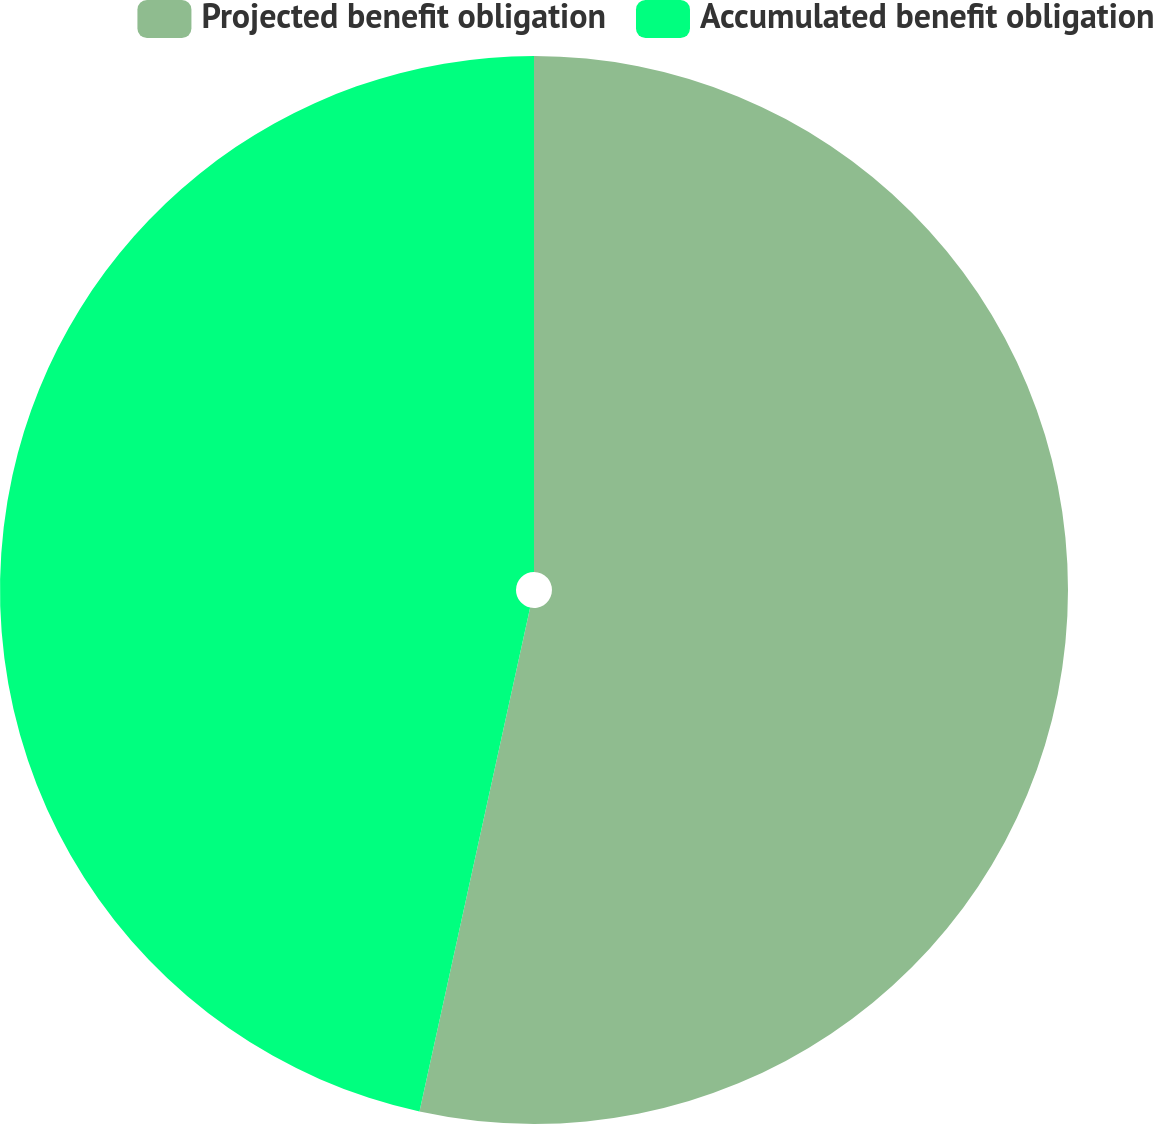Convert chart to OTSL. <chart><loc_0><loc_0><loc_500><loc_500><pie_chart><fcel>Projected benefit obligation<fcel>Accumulated benefit obligation<nl><fcel>53.44%<fcel>46.56%<nl></chart> 